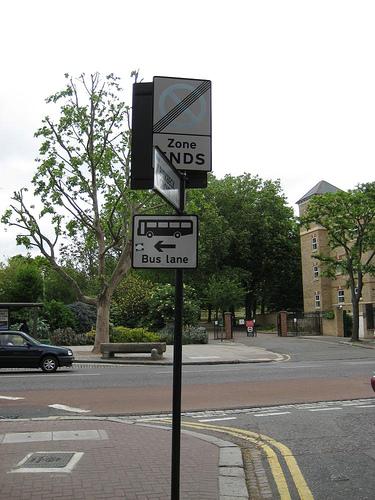What colors are the post?
Short answer required. Black. What lane does it say on the sign pointing to the left?
Concise answer only. Bus lane. Is there a Meridian?
Give a very brief answer. Yes. How many signs feature arrows?
Short answer required. 1. How many signs on the pole?
Give a very brief answer. 4. 